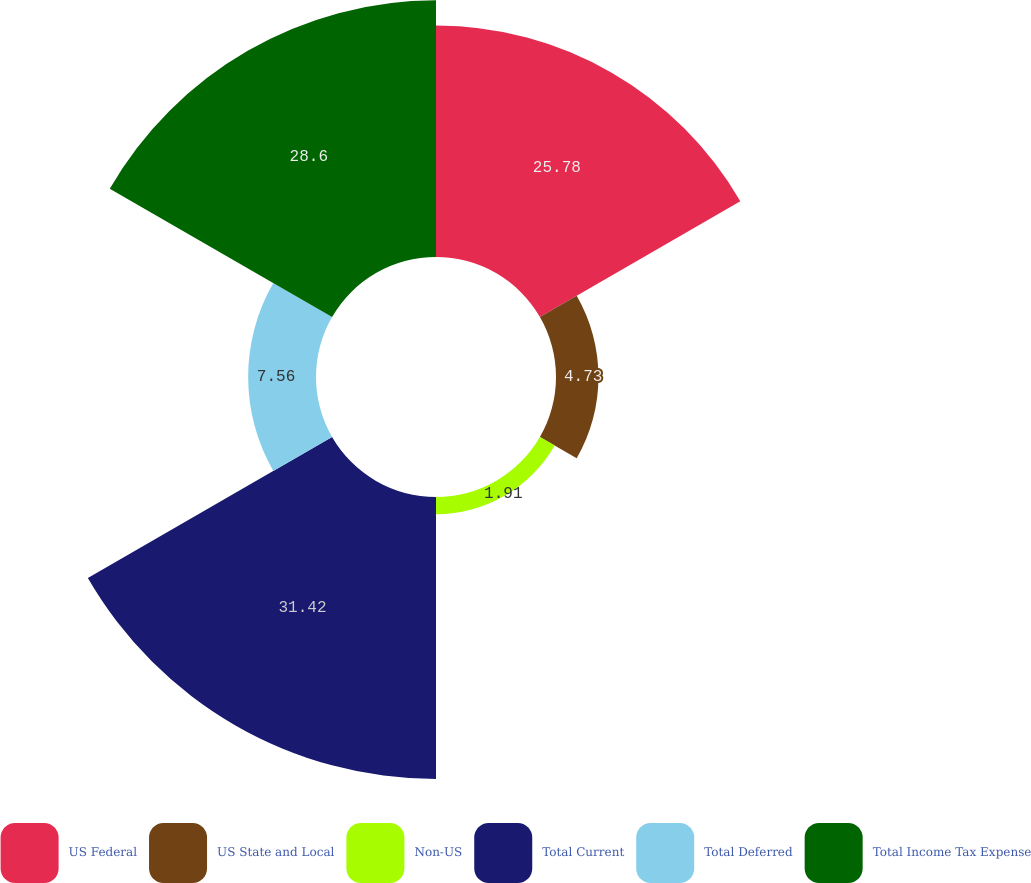Convert chart. <chart><loc_0><loc_0><loc_500><loc_500><pie_chart><fcel>US Federal<fcel>US State and Local<fcel>Non-US<fcel>Total Current<fcel>Total Deferred<fcel>Total Income Tax Expense<nl><fcel>25.78%<fcel>4.73%<fcel>1.91%<fcel>31.42%<fcel>7.56%<fcel>28.6%<nl></chart> 